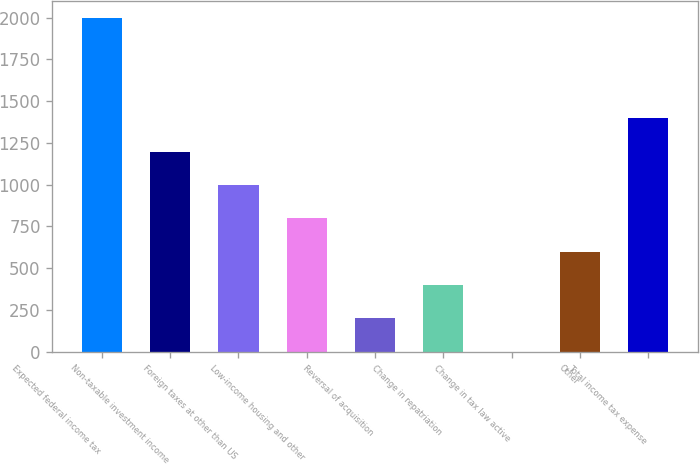Convert chart to OTSL. <chart><loc_0><loc_0><loc_500><loc_500><bar_chart><fcel>Expected federal income tax<fcel>Non-taxable investment income<fcel>Foreign taxes at other than US<fcel>Low-income housing and other<fcel>Reversal of acquisition<fcel>Change in repatriation<fcel>Change in tax law active<fcel>Other<fcel>Total income tax expense<nl><fcel>1997<fcel>1198.75<fcel>999.18<fcel>799.61<fcel>200.9<fcel>400.47<fcel>1.33<fcel>600.04<fcel>1398.32<nl></chart> 